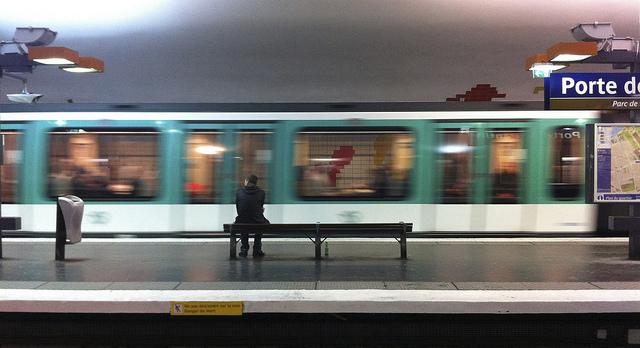What is the most likely location of this station?

Choices:
A) asia
B) europe
C) south america
D) africa europe 